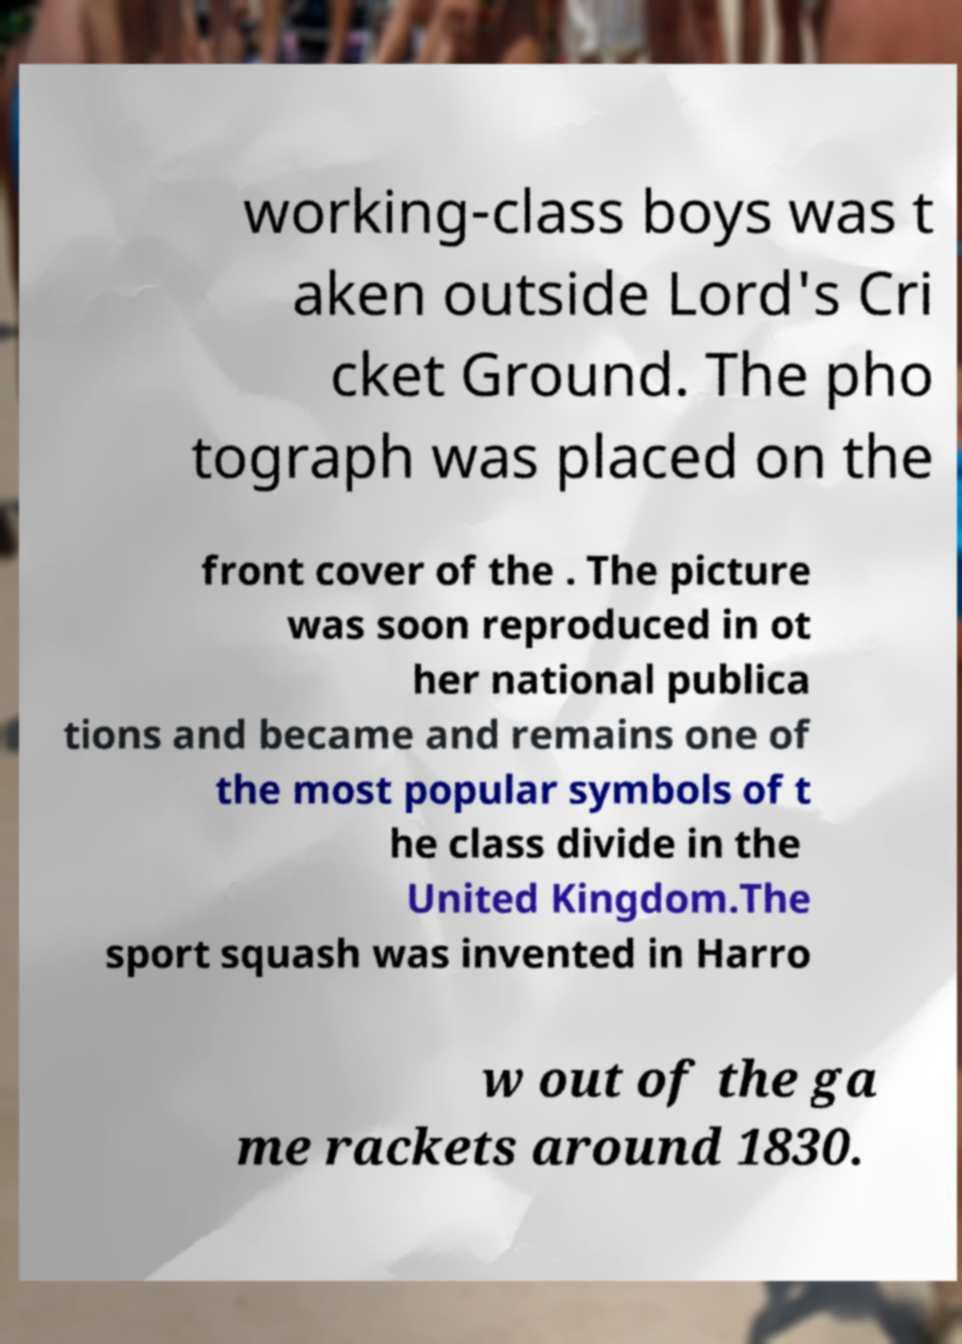Please identify and transcribe the text found in this image. working-class boys was t aken outside Lord's Cri cket Ground. The pho tograph was placed on the front cover of the . The picture was soon reproduced in ot her national publica tions and became and remains one of the most popular symbols of t he class divide in the United Kingdom.The sport squash was invented in Harro w out of the ga me rackets around 1830. 